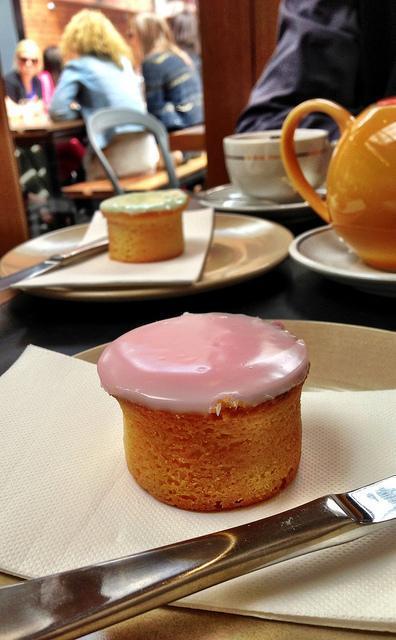How many desserts are in the photo?
Give a very brief answer. 2. How many dining tables can be seen?
Give a very brief answer. 2. How many cakes are visible?
Give a very brief answer. 2. How many people are there?
Give a very brief answer. 4. How many giraffes are not drinking?
Give a very brief answer. 0. 